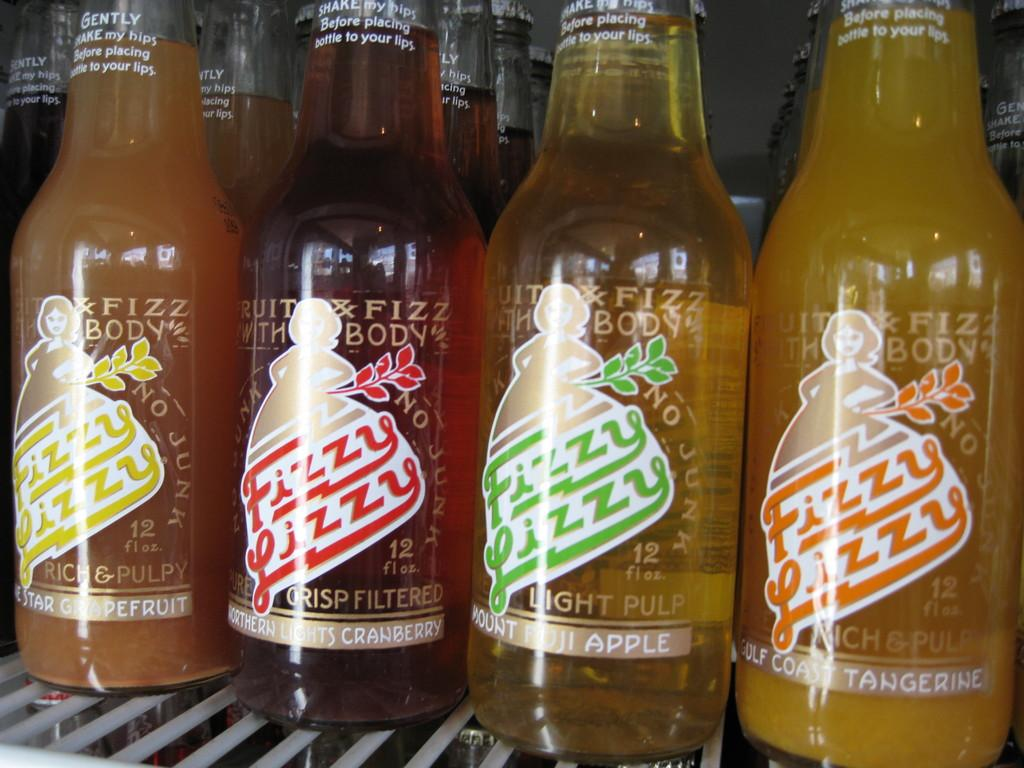Provide a one-sentence caption for the provided image. A collection of Fizzy Lizzy drinks in different flavors, such as Tangerine and Mount Fuji Apple. 